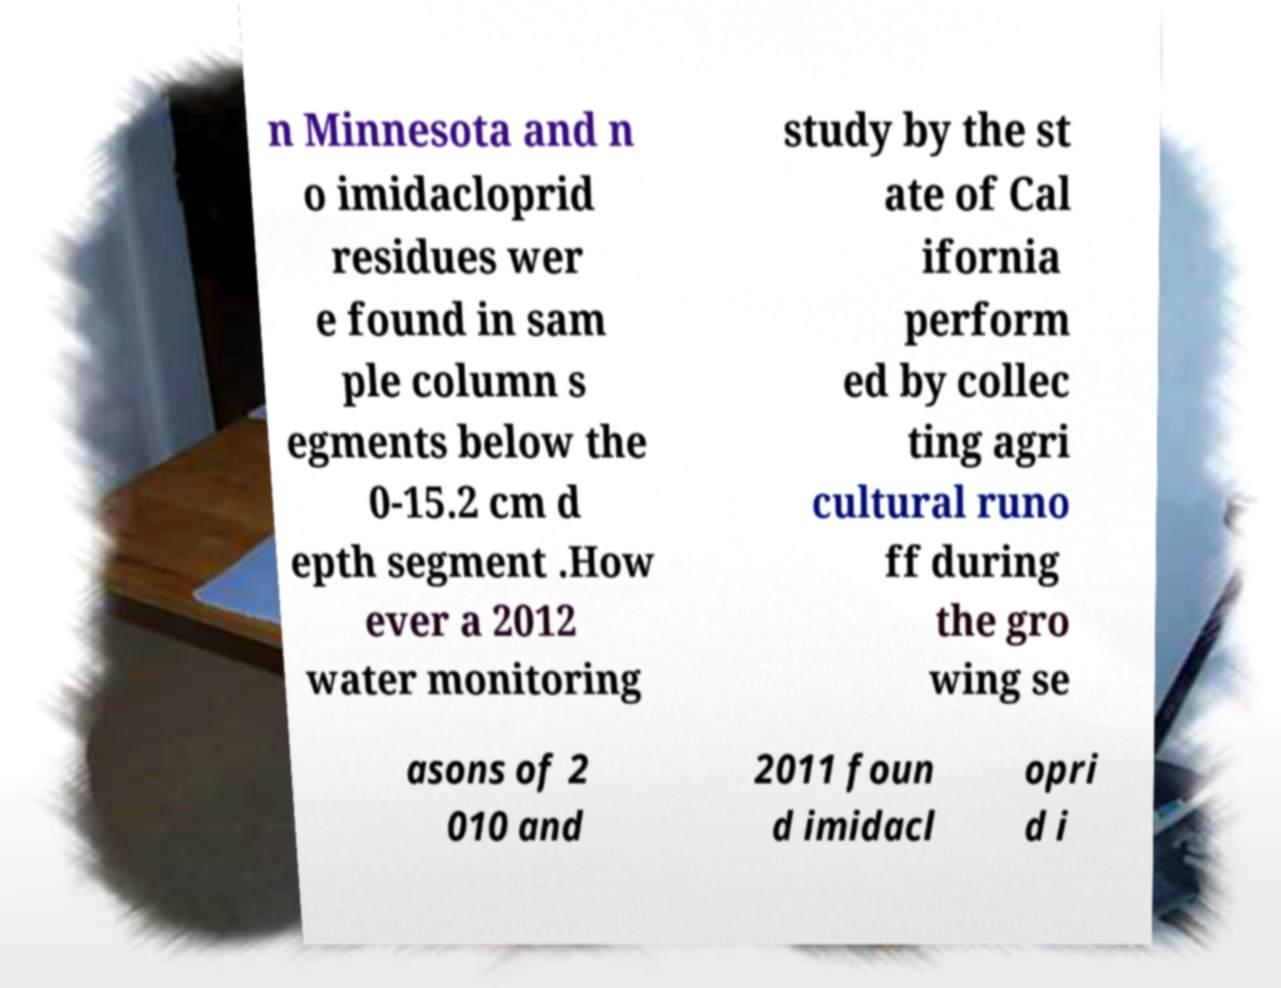Could you assist in decoding the text presented in this image and type it out clearly? n Minnesota and n o imidacloprid residues wer e found in sam ple column s egments below the 0-15.2 cm d epth segment .How ever a 2012 water monitoring study by the st ate of Cal ifornia perform ed by collec ting agri cultural runo ff during the gro wing se asons of 2 010 and 2011 foun d imidacl opri d i 